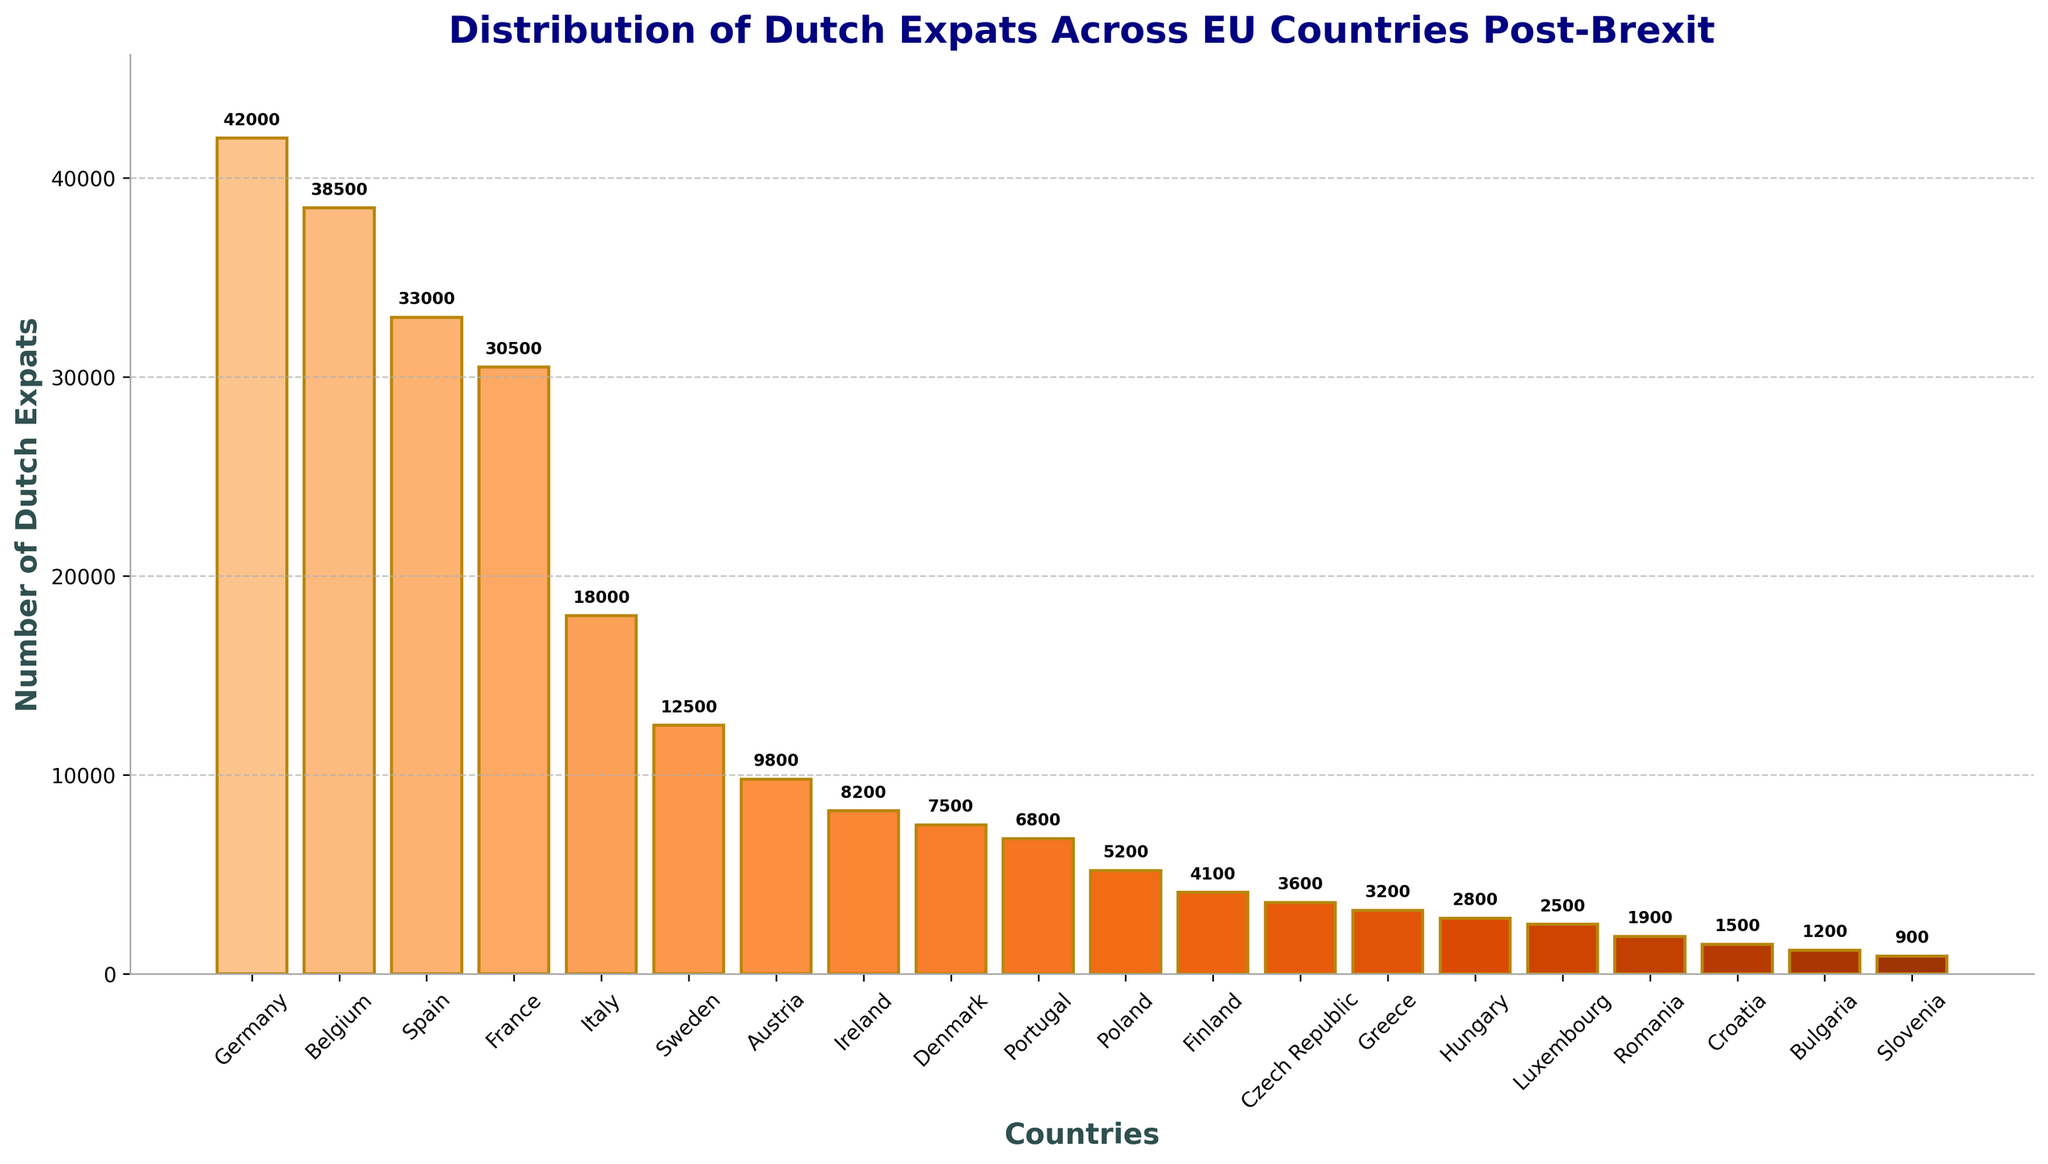What is the total number of Dutch expats in Germany and Belgium? Adding the number of Dutch expats in Germany (42,000) and Belgium (38,500) gives the total: 42,000 + 38,500 = 80,500.
Answer: 80,500 How many more Dutch expats are there in Spain compared to Austria? The number of Dutch expats in Spain is 33,000 and in Austria is 9,800. The difference is 33,000 - 9,800 = 23,200.
Answer: 23,200 Which country has the smallest number of Dutch expats? By looking at the height of the bars, Slovenia has the smallest number of Dutch expats, which is 900.
Answer: Slovenia Are there more Dutch expats in Ireland or Portugal? Comparing the bars for Ireland and Portugal shows that Ireland has 8,200 expats, while Portugal has 6,800. Therefore, Ireland has more.
Answer: Ireland What is the average number of Dutch expats across all listed countries? Summing all the expats: 42,000 + 38,500 + 33,000 + 30,500 + 18,000 + 12,500 + 9,800 + 8,200 + 7,500 + 6,800 + 5,200 + 4,100 + 3,600 + 3,200 + 2,800 + 2,500 + 1,900 + 1,500 + 1,200 + 900 = 263,700. Dividing by the number of countries (20) gives: 263,700 / 20 = 13,185.
Answer: 13,185 Which countries have more than 30,000 Dutch expats? Countries with bars taller than the 30,000 mark are Germany (42,000), Belgium (38,500), Spain (33,000), and France (30,500).
Answer: Germany, Belgium, Spain, France What is the total number of Dutch expats in the countries with fewer than 5,000 expats? Summing the numbers for Poland (5,200), Finland (4,100), Czech Republic (3,600), Greece (3,200), Hungary (2,800), Luxembourg (2,500), Romania (1,900), Croatia (1,500), Bulgaria (1,200), and Slovenia (900): 5,200 + 4,100 + 3,600 + 3,200 + 2,800 + 2,500 + 1,900 + 1,500 + 1,200 + 900 = 26,900.
Answer: 26,900 How many fewer Dutch expats are there in Sweden compared to Italy? Subtracting the number of expats in Italy (18,000) from those in Sweden (12,500) gives the difference: 18,000 - 12,500 = 5,500.
Answer: 5,500 What percentage of the total number of Dutch expats reside in Germany? Germany has 42,000 Dutch expats out of a total of 263,700. The percentage is (42,000 / 263,700) * 100 ≈ 15.92%.
Answer: 15.92% Are there more Dutch expats in France or Sweden? Comparing the bars, France has 30,500 expats and Sweden has 12,500. Therefore, France has more.
Answer: France 